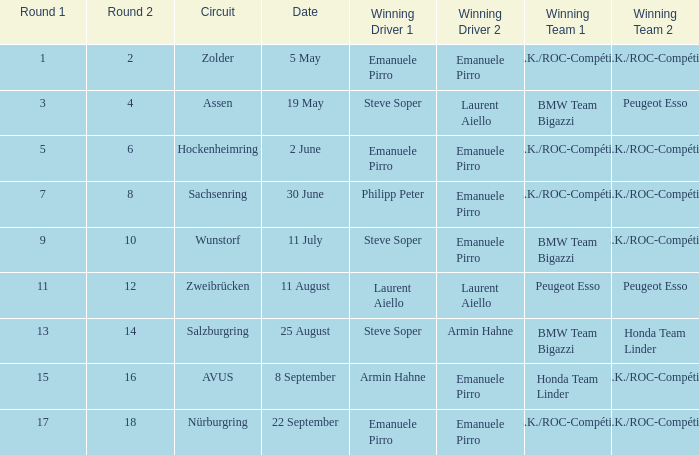Who emerged as the victorious driver in the race on may 5th? Emanuele Pirro Emanuele Pirro. 